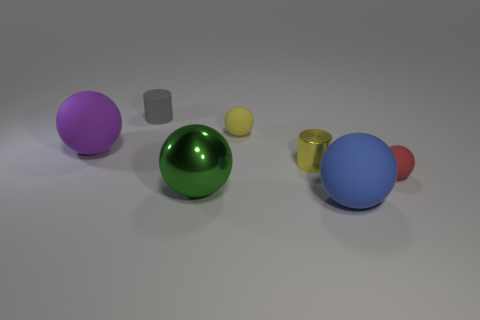Is the size of the rubber sphere that is right of the big blue rubber thing the same as the cylinder on the left side of the large green ball?
Offer a terse response. Yes. Is the number of tiny red rubber balls less than the number of small red rubber cubes?
Keep it short and to the point. No. What number of big purple objects are in front of the tiny yellow cylinder?
Make the answer very short. 0. What material is the big green sphere?
Your answer should be compact. Metal. Does the small shiny cylinder have the same color as the big shiny object?
Offer a terse response. No. Are there fewer metallic objects behind the small yellow shiny cylinder than cyan matte things?
Make the answer very short. No. What is the color of the tiny matte object that is on the right side of the big blue ball?
Ensure brevity in your answer.  Red. What is the shape of the large blue thing?
Offer a very short reply. Sphere. There is a small yellow object that is in front of the small matte sphere left of the big blue rubber thing; are there any shiny cylinders on the left side of it?
Your answer should be very brief. No. There is a cylinder that is behind the yellow object behind the large purple object behind the yellow shiny thing; what is its color?
Provide a short and direct response. Gray. 